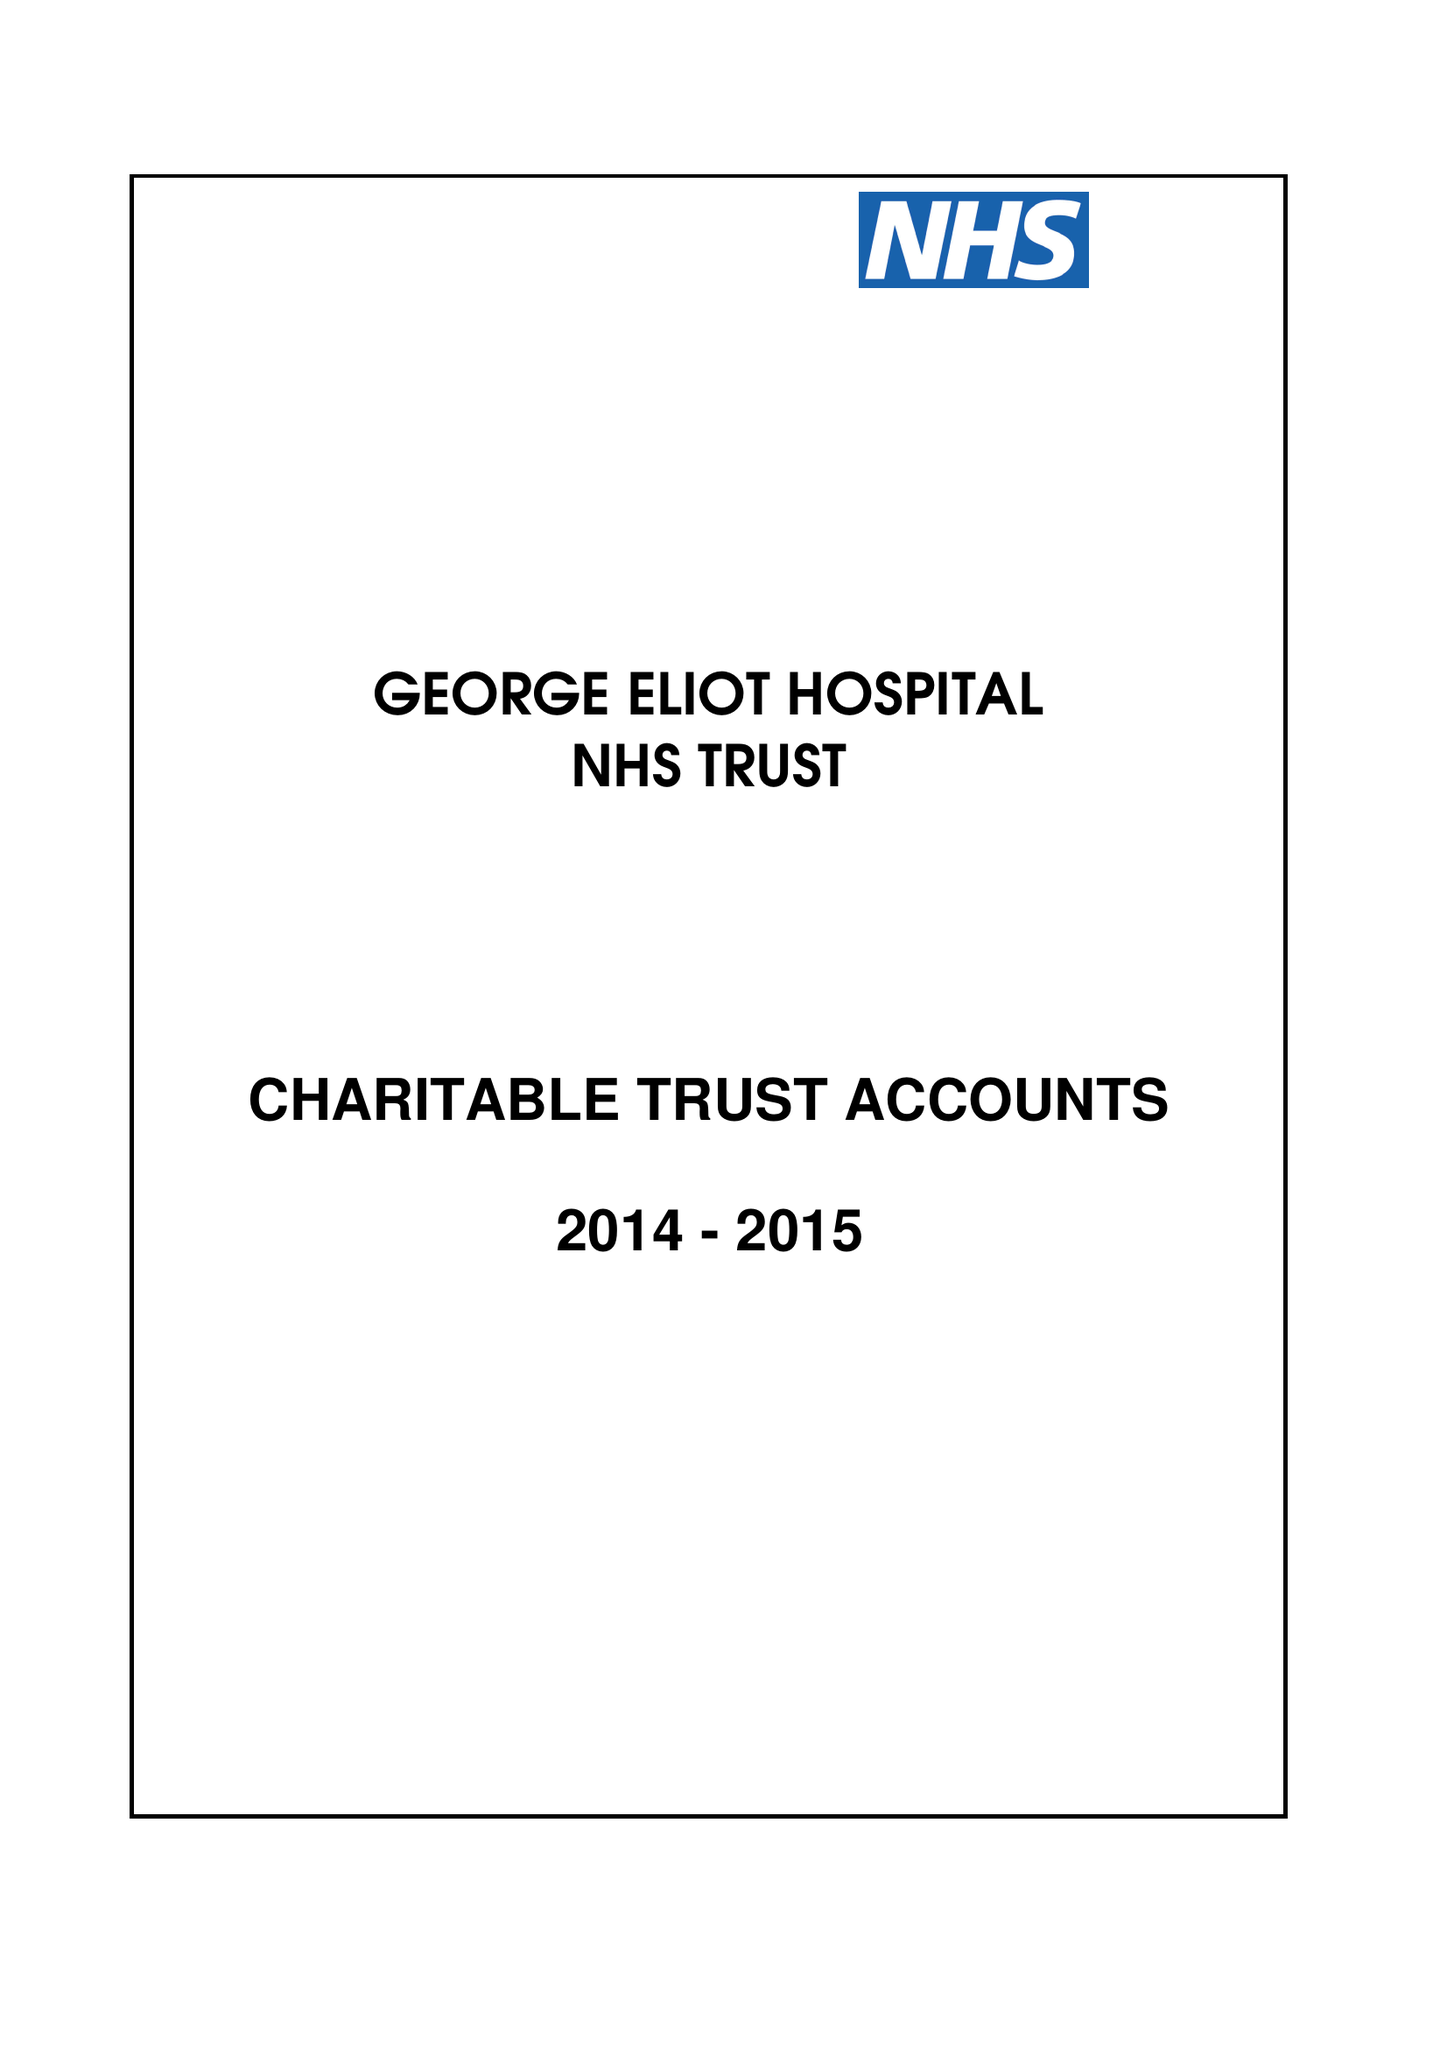What is the value for the charity_number?
Answer the question using a single word or phrase. 1057607 